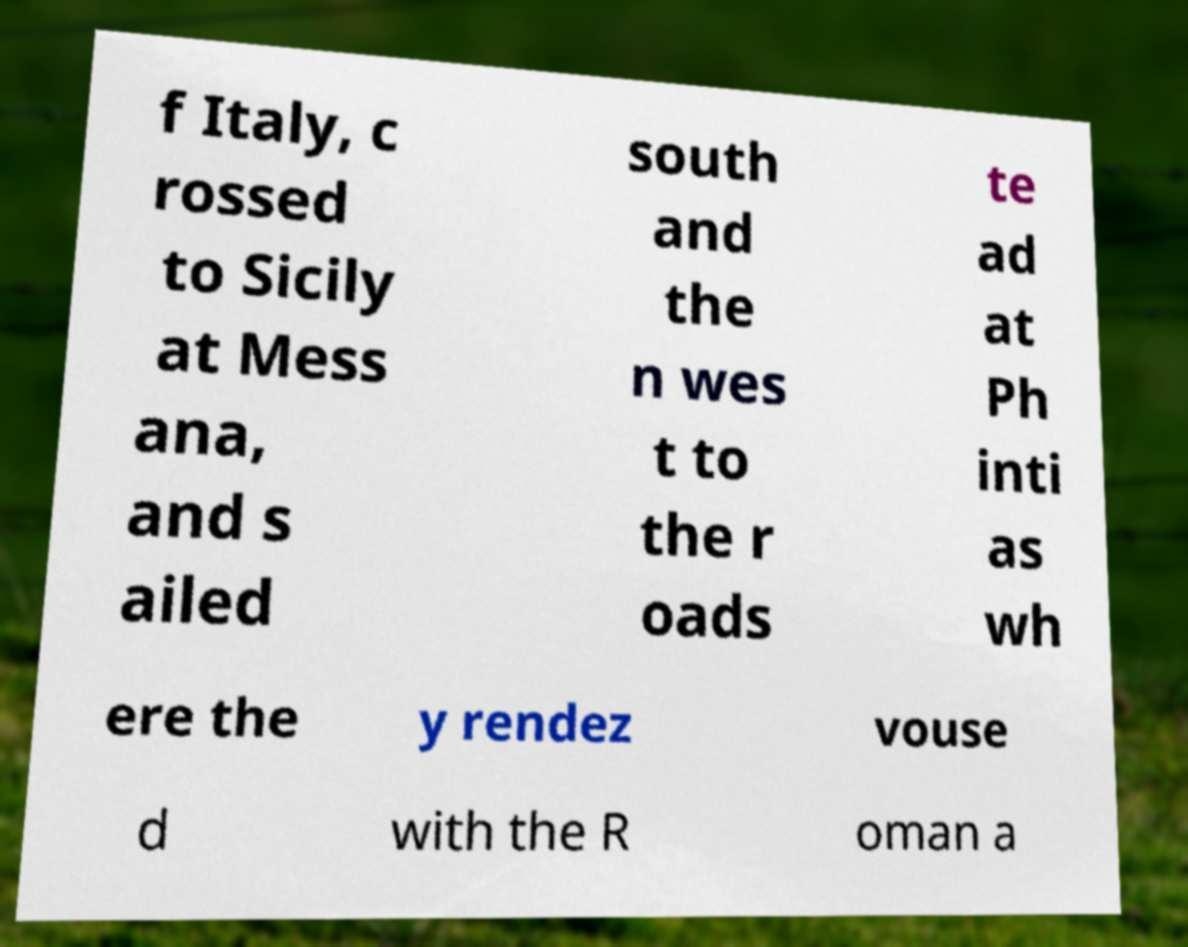Could you assist in decoding the text presented in this image and type it out clearly? f Italy, c rossed to Sicily at Mess ana, and s ailed south and the n wes t to the r oads te ad at Ph inti as wh ere the y rendez vouse d with the R oman a 